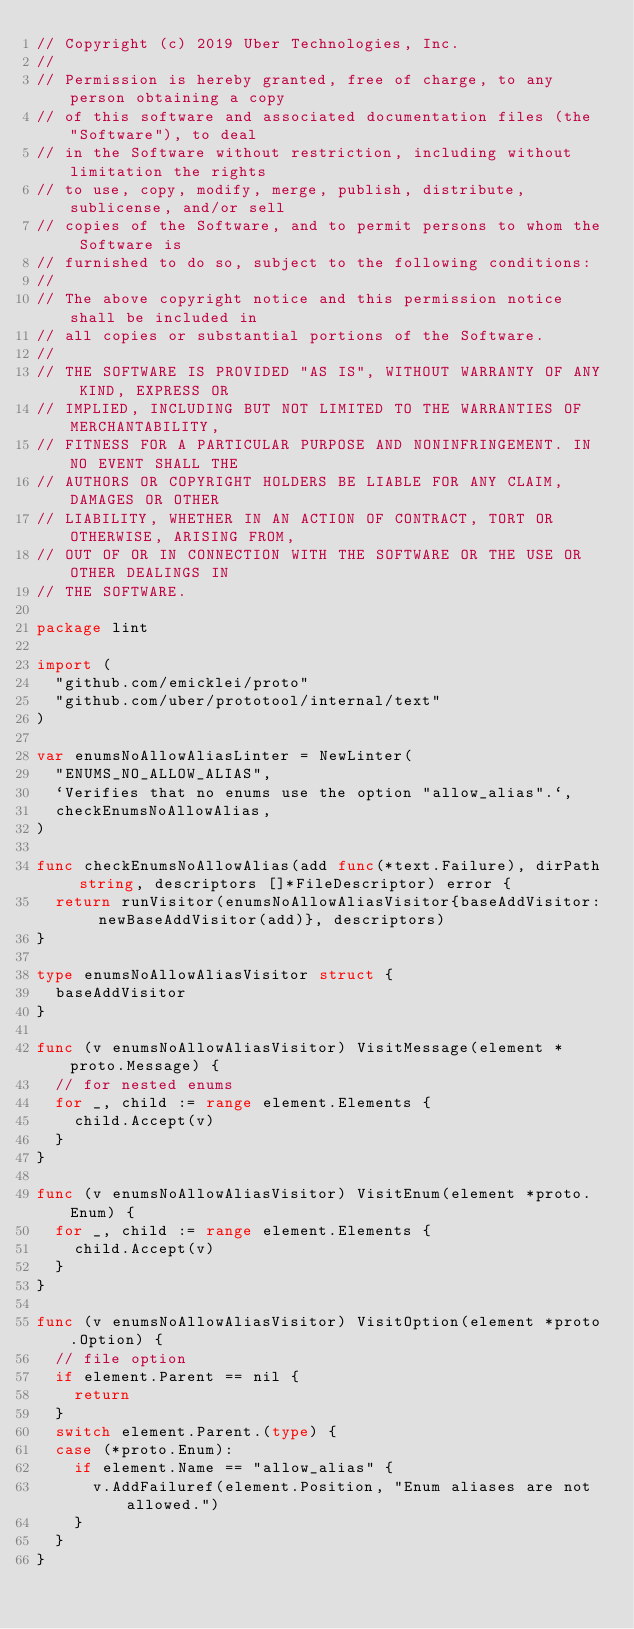Convert code to text. <code><loc_0><loc_0><loc_500><loc_500><_Go_>// Copyright (c) 2019 Uber Technologies, Inc.
//
// Permission is hereby granted, free of charge, to any person obtaining a copy
// of this software and associated documentation files (the "Software"), to deal
// in the Software without restriction, including without limitation the rights
// to use, copy, modify, merge, publish, distribute, sublicense, and/or sell
// copies of the Software, and to permit persons to whom the Software is
// furnished to do so, subject to the following conditions:
//
// The above copyright notice and this permission notice shall be included in
// all copies or substantial portions of the Software.
//
// THE SOFTWARE IS PROVIDED "AS IS", WITHOUT WARRANTY OF ANY KIND, EXPRESS OR
// IMPLIED, INCLUDING BUT NOT LIMITED TO THE WARRANTIES OF MERCHANTABILITY,
// FITNESS FOR A PARTICULAR PURPOSE AND NONINFRINGEMENT. IN NO EVENT SHALL THE
// AUTHORS OR COPYRIGHT HOLDERS BE LIABLE FOR ANY CLAIM, DAMAGES OR OTHER
// LIABILITY, WHETHER IN AN ACTION OF CONTRACT, TORT OR OTHERWISE, ARISING FROM,
// OUT OF OR IN CONNECTION WITH THE SOFTWARE OR THE USE OR OTHER DEALINGS IN
// THE SOFTWARE.

package lint

import (
	"github.com/emicklei/proto"
	"github.com/uber/prototool/internal/text"
)

var enumsNoAllowAliasLinter = NewLinter(
	"ENUMS_NO_ALLOW_ALIAS",
	`Verifies that no enums use the option "allow_alias".`,
	checkEnumsNoAllowAlias,
)

func checkEnumsNoAllowAlias(add func(*text.Failure), dirPath string, descriptors []*FileDescriptor) error {
	return runVisitor(enumsNoAllowAliasVisitor{baseAddVisitor: newBaseAddVisitor(add)}, descriptors)
}

type enumsNoAllowAliasVisitor struct {
	baseAddVisitor
}

func (v enumsNoAllowAliasVisitor) VisitMessage(element *proto.Message) {
	// for nested enums
	for _, child := range element.Elements {
		child.Accept(v)
	}
}

func (v enumsNoAllowAliasVisitor) VisitEnum(element *proto.Enum) {
	for _, child := range element.Elements {
		child.Accept(v)
	}
}

func (v enumsNoAllowAliasVisitor) VisitOption(element *proto.Option) {
	// file option
	if element.Parent == nil {
		return
	}
	switch element.Parent.(type) {
	case (*proto.Enum):
		if element.Name == "allow_alias" {
			v.AddFailuref(element.Position, "Enum aliases are not allowed.")
		}
	}
}
</code> 